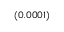<formula> <loc_0><loc_0><loc_500><loc_500>_ { ( 0 . 0 0 0 1 ) }</formula> 